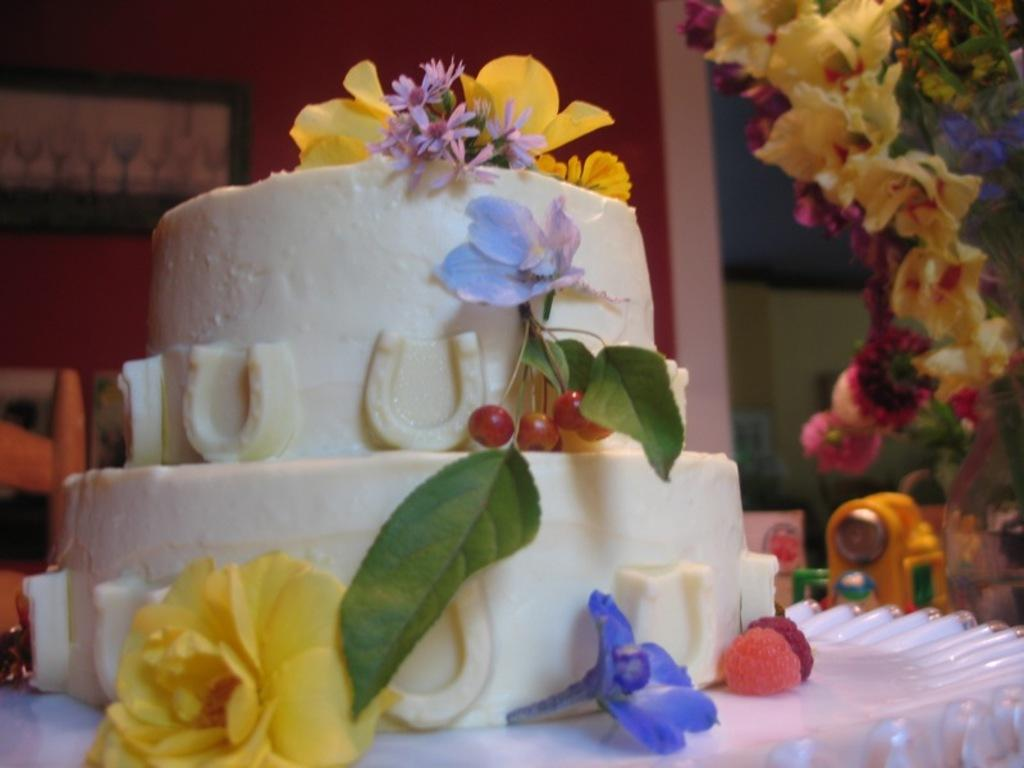What type of cake is shown in the image? There is a step cake in the image. How is the cake decorated? The cake is decorated with flowers and fruits. What other objects can be seen in the image? There are objects in the image, but their specific details are not mentioned in the provided facts. What is the location of the photo frame in the image? The photo frame is in the background of the image and is attached to the wall. Can you tell me how many ants are crawling on the cake in the image? There is no mention of ants in the provided facts, so we cannot determine if any are present on the cake. Who is the expert in the image? There is no mention of an expert or any person in the provided facts, so we cannot determine if there is an expert in the image. 